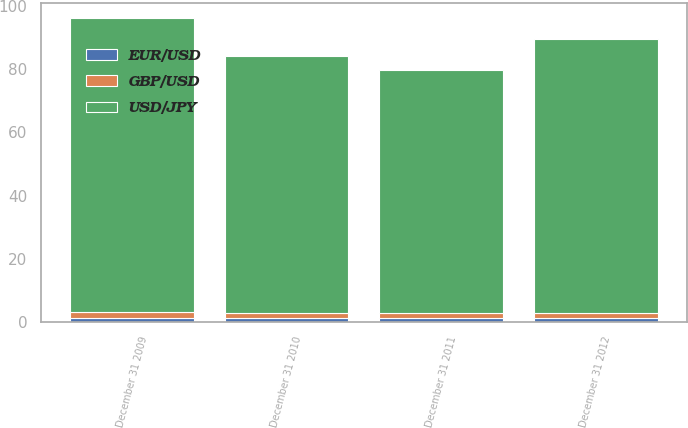Convert chart to OTSL. <chart><loc_0><loc_0><loc_500><loc_500><stacked_bar_chart><ecel><fcel>December 31 2009<fcel>December 31 2010<fcel>December 31 2011<fcel>December 31 2012<nl><fcel>EUR/USD<fcel>1.43<fcel>1.34<fcel>1.3<fcel>1.32<nl><fcel>GBP/USD<fcel>1.62<fcel>1.56<fcel>1.55<fcel>1.62<nl><fcel>USD/JPY<fcel>93.08<fcel>81.22<fcel>76.92<fcel>86.73<nl></chart> 